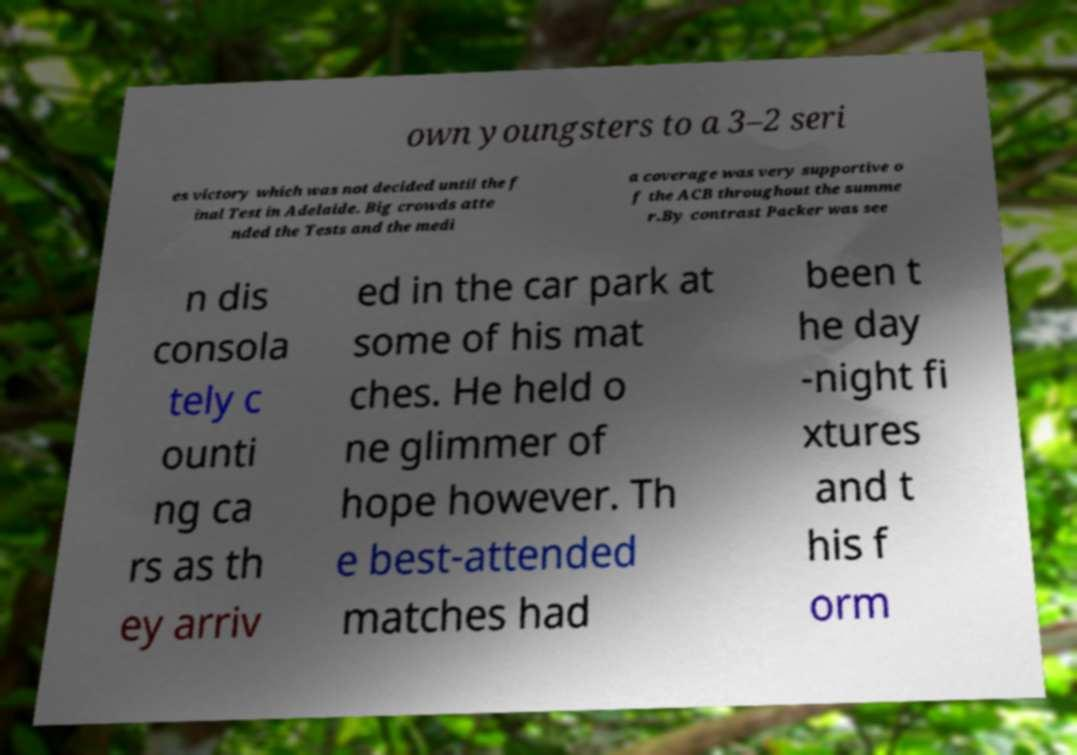For documentation purposes, I need the text within this image transcribed. Could you provide that? own youngsters to a 3–2 seri es victory which was not decided until the f inal Test in Adelaide. Big crowds atte nded the Tests and the medi a coverage was very supportive o f the ACB throughout the summe r.By contrast Packer was see n dis consola tely c ounti ng ca rs as th ey arriv ed in the car park at some of his mat ches. He held o ne glimmer of hope however. Th e best-attended matches had been t he day -night fi xtures and t his f orm 